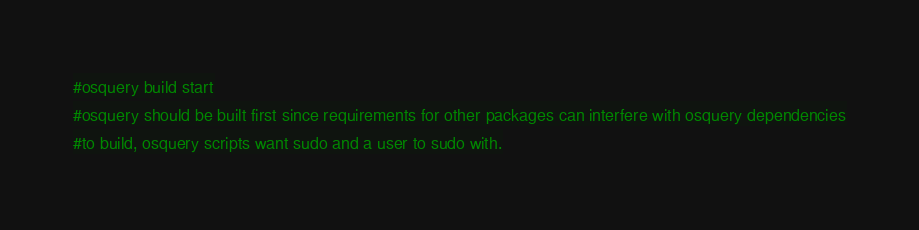<code> <loc_0><loc_0><loc_500><loc_500><_Dockerfile_>
#osquery build start
#osquery should be built first since requirements for other packages can interfere with osquery dependencies
#to build, osquery scripts want sudo and a user to sudo with.</code> 